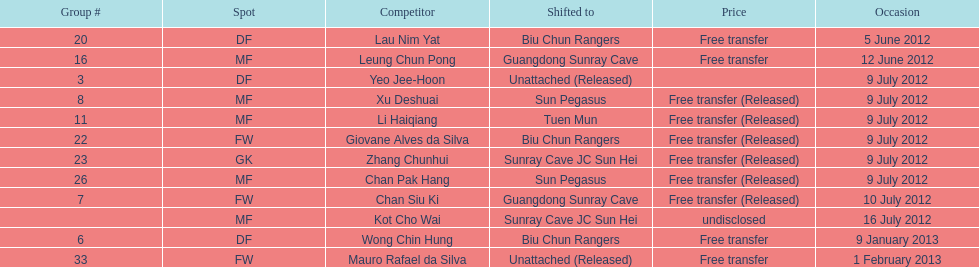What is the total number of players listed? 12. 